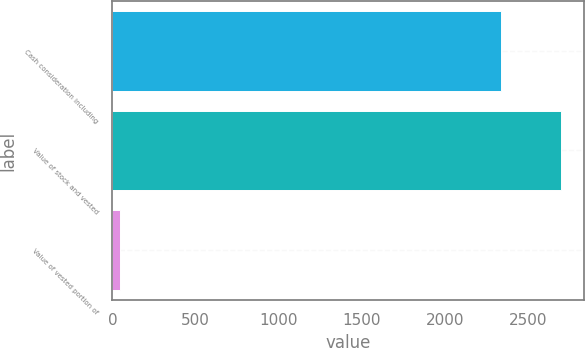Convert chart to OTSL. <chart><loc_0><loc_0><loc_500><loc_500><bar_chart><fcel>Cash consideration including<fcel>Value of stock and vested<fcel>Value of vested portion of<nl><fcel>2335<fcel>2697<fcel>47<nl></chart> 